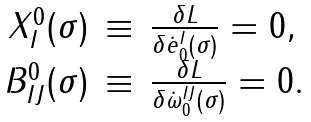<formula> <loc_0><loc_0><loc_500><loc_500>\begin{array} { r c l } X ^ { 0 } _ { I } ( \sigma ) & \equiv & \frac { \delta L } { \delta \dot { e } _ { 0 } ^ { I } ( \sigma ) } = 0 , \\ B ^ { 0 } _ { I J } ( \sigma ) & \equiv & \frac { \delta L } { \delta \dot { \omega } _ { 0 } ^ { I J } ( \sigma ) } = 0 . \end{array}</formula> 